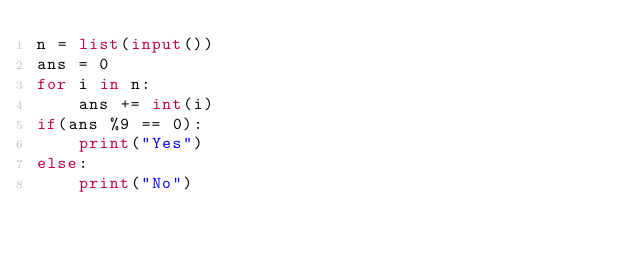<code> <loc_0><loc_0><loc_500><loc_500><_Python_>n = list(input())
ans = 0
for i in n:
    ans += int(i)
if(ans %9 == 0):
    print("Yes")
else:
    print("No")</code> 